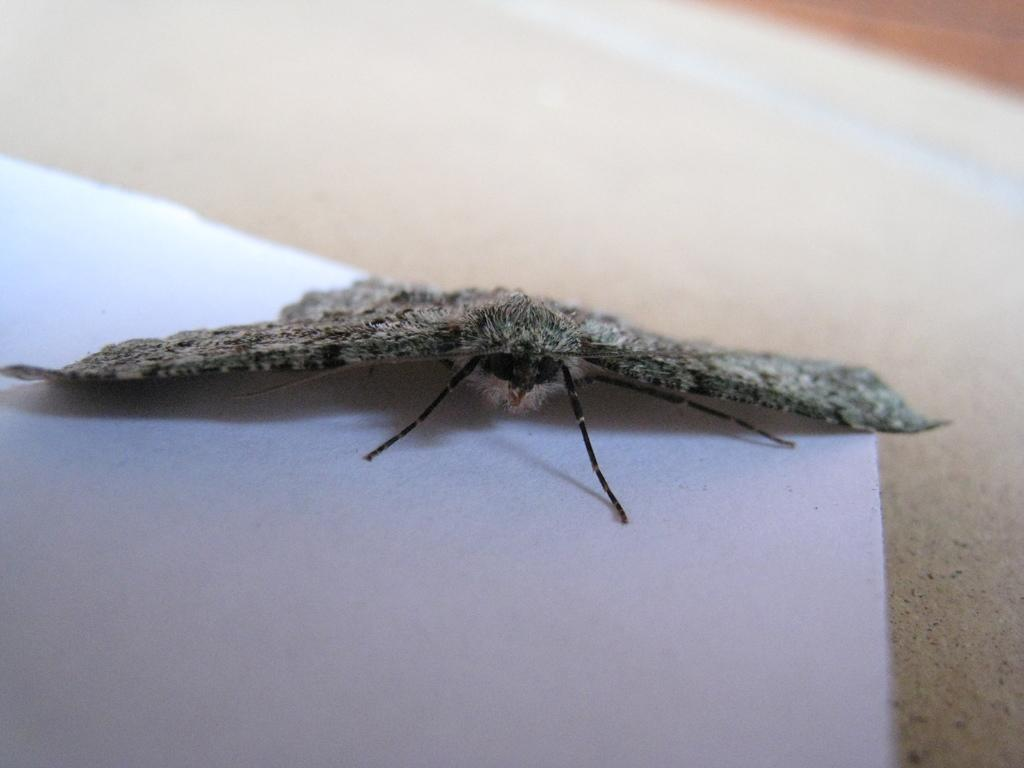What is the main subject of the picture? The main subject of the picture is an insect. Where is the insect located in the image? The insect is on a white surface. Can you describe the background of the image? The background of the image is slightly blurred. What type of bells can be heard ringing in the background of the image? There are no bells present in the image, and therefore no sound can be heard. 